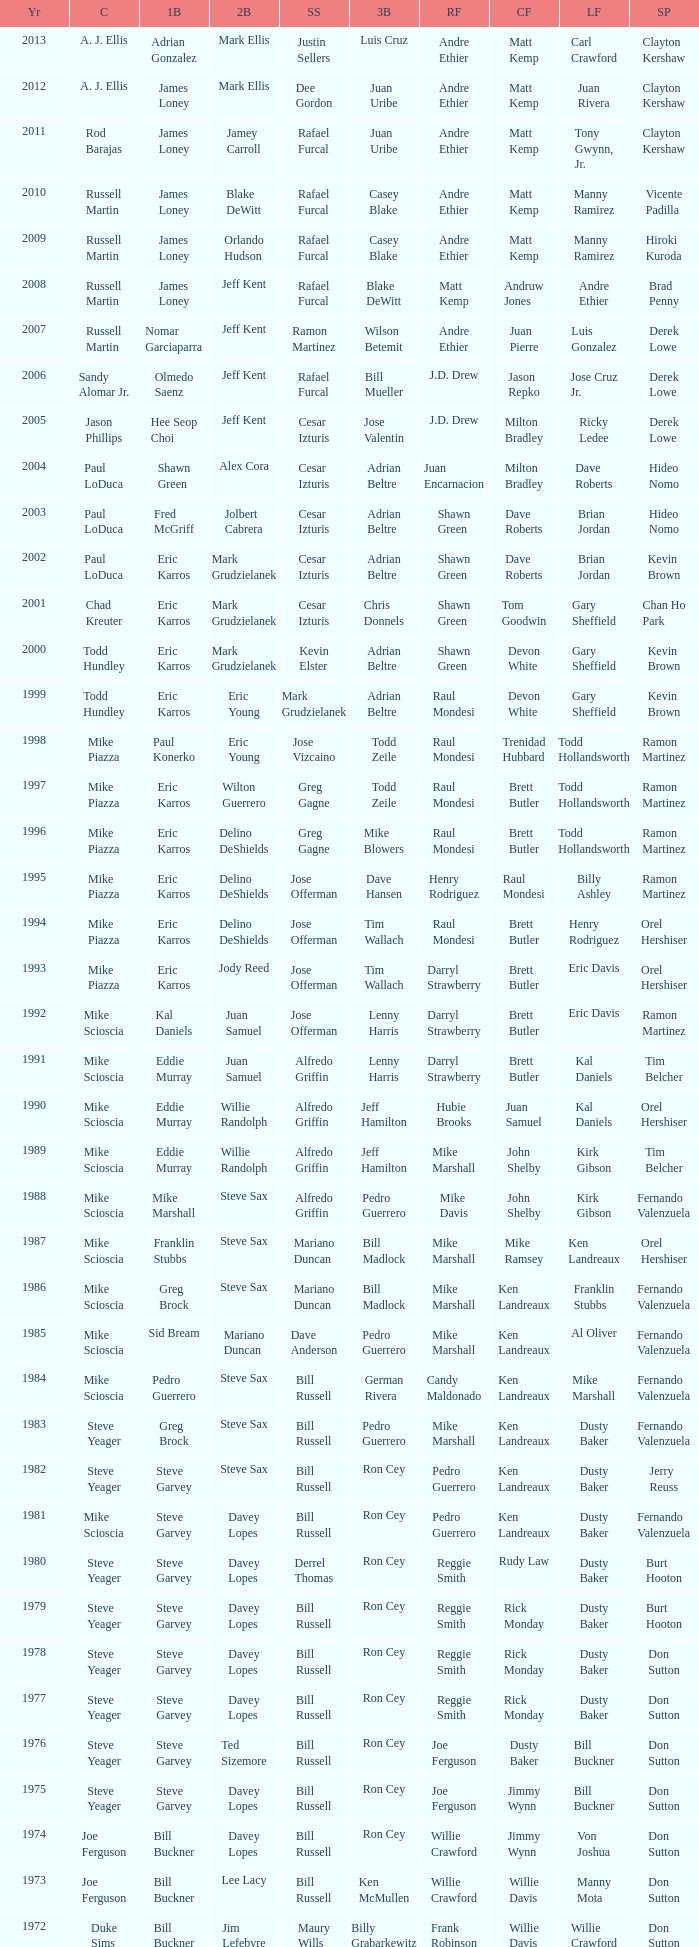Who was the RF when the SP was vicente padilla? Andre Ethier. 